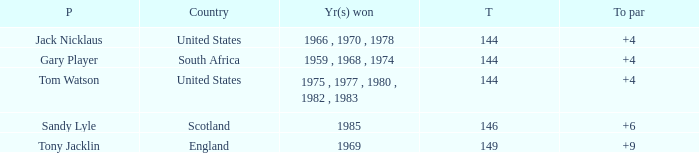What was Tom Watson's lowest To par when the total was larger than 144? None. 